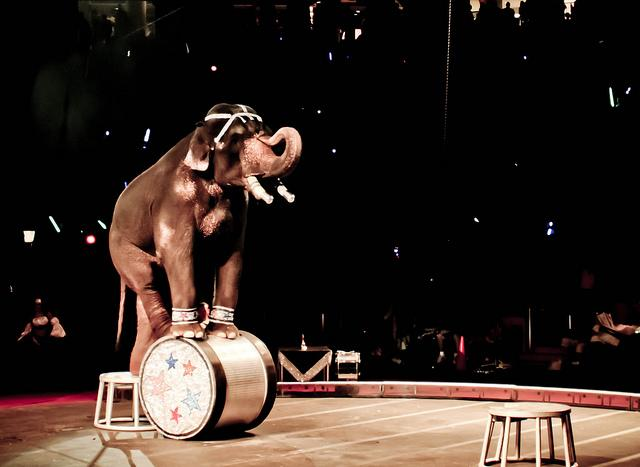Why is the elephant placing its legs on the wheel? show trick 